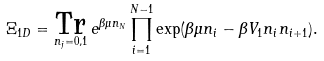Convert formula to latex. <formula><loc_0><loc_0><loc_500><loc_500>\Xi _ { 1 D } = \underset { n _ { j } = 0 , 1 } { \text {Tr} } \, e ^ { \beta \mu n _ { N } } \prod _ { i = 1 } ^ { N - 1 } \exp ( \beta \mu n _ { i } - \beta V _ { 1 } n _ { i } n _ { i + 1 } ) .</formula> 